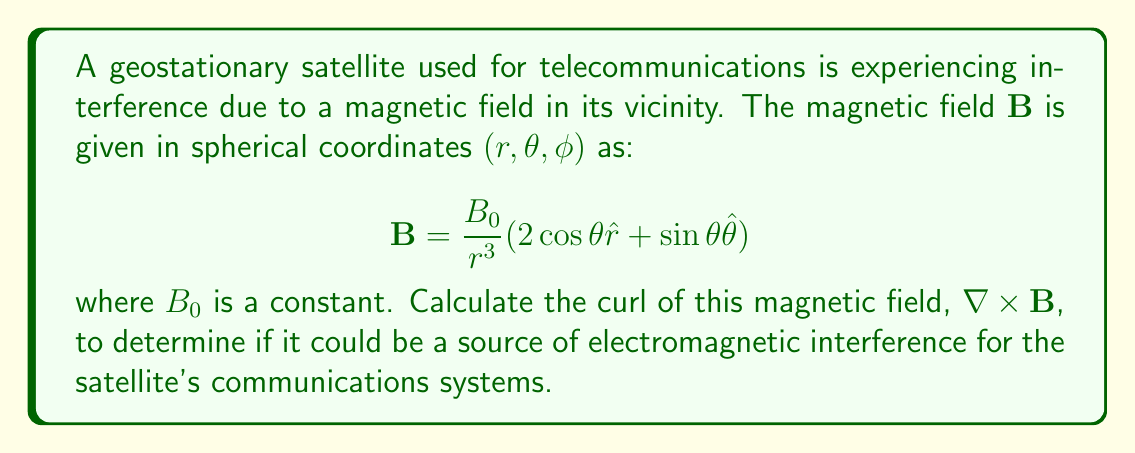Show me your answer to this math problem. To calculate the curl of the magnetic field, we'll use the curl formula in spherical coordinates:

$$\nabla \times \mathbf{B} = \frac{1}{r \sin\theta}\left(\frac{\partial}{\partial \theta}(B_\phi \sin\theta) - \frac{\partial B_\theta}{\partial \phi}\right)\hat{r} + \frac{1}{r}\left(\frac{1}{\sin\theta}\frac{\partial B_r}{\partial \phi} - \frac{\partial}{\partial r}(rB_\phi)\right)\hat{\theta} + \frac{1}{r}\left(\frac{\partial}{\partial r}(rB_\theta) - \frac{\partial B_r}{\partial \theta}\right)\hat{\phi}$$

Step 1: Identify the components of $\mathbf{B}$:
$B_r = \frac{2B_0}{r^3}\cos\theta$
$B_\theta = \frac{B_0}{r^3}\sin\theta$
$B_\phi = 0$

Step 2: Calculate the partial derivatives:
$\frac{\partial}{\partial \theta}(B_\phi \sin\theta) = 0$
$\frac{\partial B_\theta}{\partial \phi} = 0$
$\frac{\partial B_r}{\partial \phi} = 0$
$\frac{\partial}{\partial r}(rB_\phi) = 0$
$\frac{\partial}{\partial r}(rB_\theta) = \frac{\partial}{\partial r}(\frac{B_0}{r^2}\sin\theta) = -\frac{2B_0}{r^3}\sin\theta$
$\frac{\partial B_r}{\partial \theta} = \frac{\partial}{\partial \theta}(\frac{2B_0}{r^3}\cos\theta) = -\frac{2B_0}{r^3}\sin\theta$

Step 3: Substitute into the curl formula:
$\nabla \times \mathbf{B} = 0\hat{r} + 0\hat{\theta} + \frac{1}{r}\left(-\frac{2B_0}{r^3}\sin\theta - (-\frac{2B_0}{r^3}\sin\theta)\right)\hat{\phi}$

Step 4: Simplify:
$\nabla \times \mathbf{B} = 0\hat{r} + 0\hat{\theta} + 0\hat{\phi} = \mathbf{0}$

The curl of the magnetic field is zero, indicating that it is a conservative field and not a source of electromagnetic interference for the satellite's communications systems.
Answer: $\nabla \times \mathbf{B} = \mathbf{0}$ 